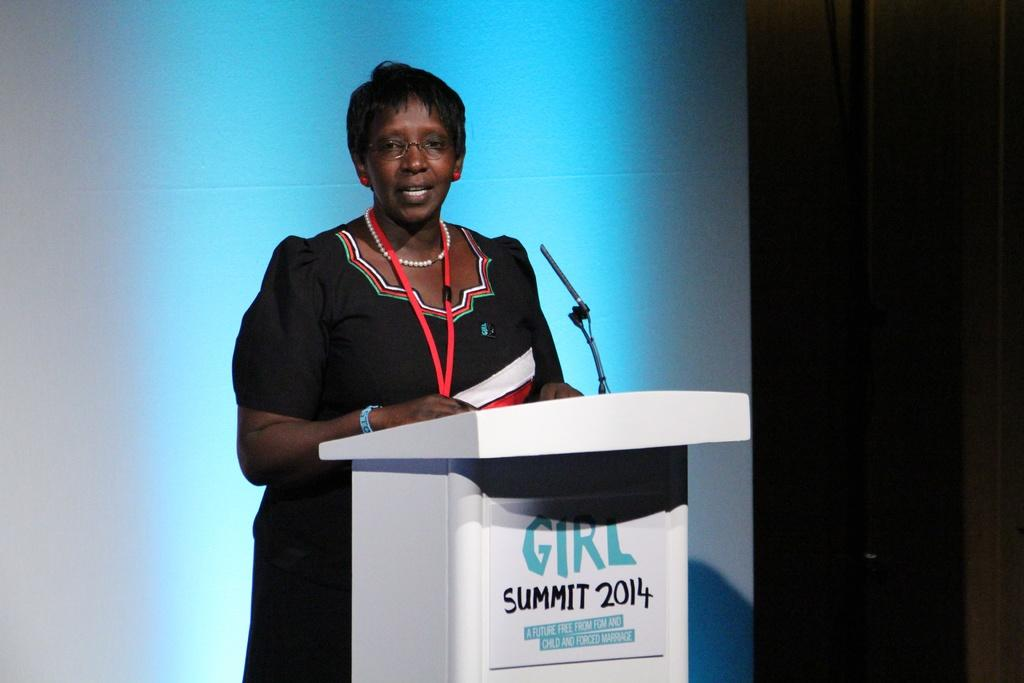<image>
Relay a brief, clear account of the picture shown. Speaker standing behind a podium with Girl Summit 2014 on the front of the podium. 